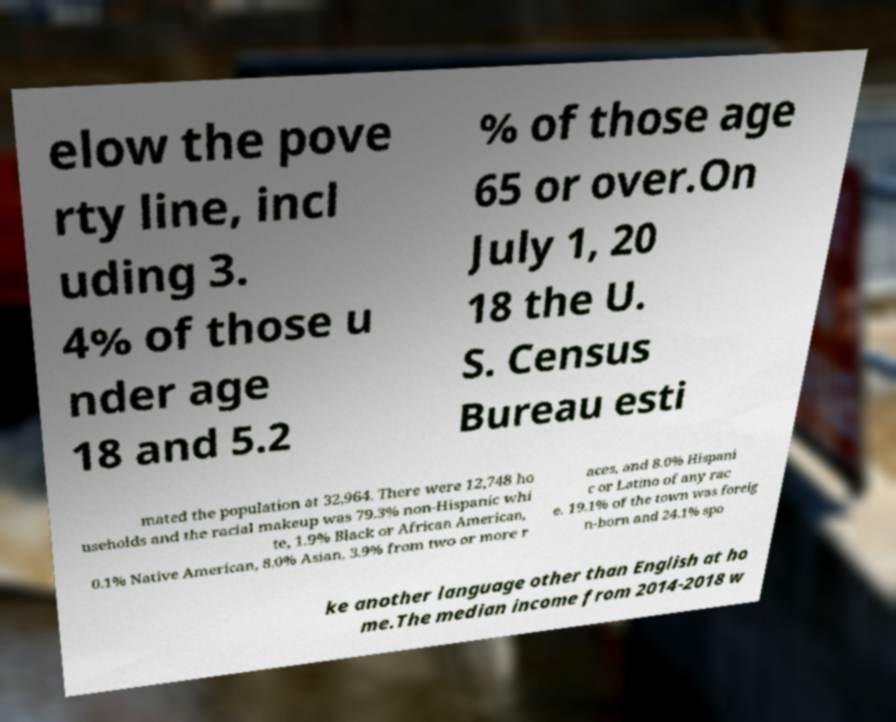What messages or text are displayed in this image? I need them in a readable, typed format. elow the pove rty line, incl uding 3. 4% of those u nder age 18 and 5.2 % of those age 65 or over.On July 1, 20 18 the U. S. Census Bureau esti mated the population at 32,964. There were 12,748 ho useholds and the racial makeup was 79.3% non-Hispanic whi te, 1.9% Black or African American, 0.1% Native American, 8.0% Asian, 3.9% from two or more r aces, and 8.0% Hispani c or Latino of any rac e. 19.1% of the town was foreig n-born and 24.1% spo ke another language other than English at ho me.The median income from 2014-2018 w 